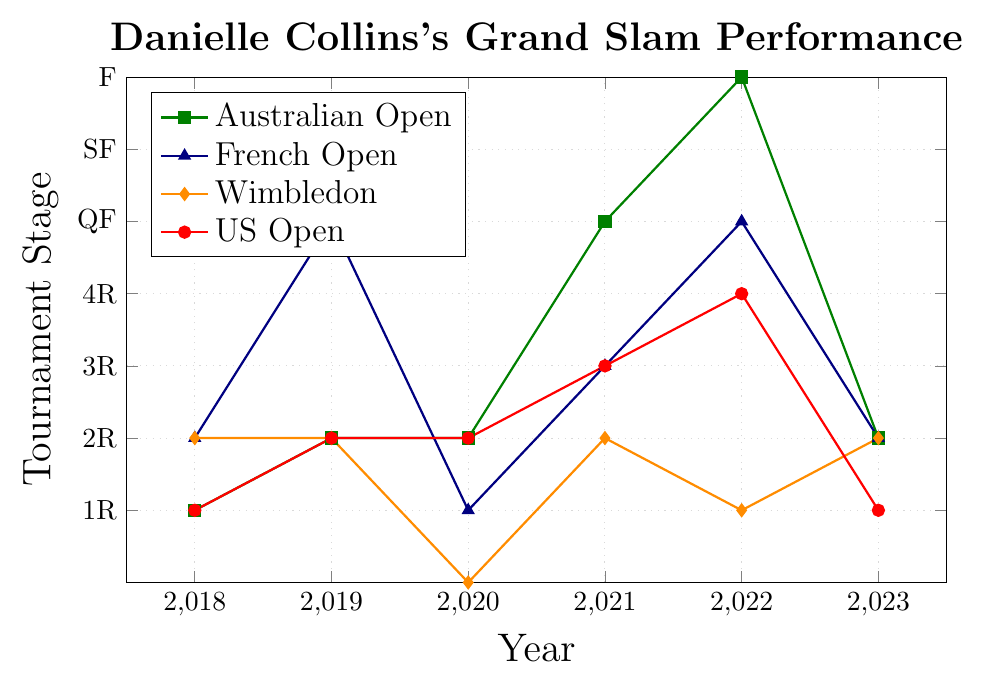what is the highest stage Danielle Collins reached in the Australian Open? To find the highest stage in the Australian Open, look at the highest data point in the Australian Open series. The highest stage is the final (F) in 2022.
Answer: F Between which years did Danielle Collins show the most improvement in the French Open? Evaluate the increase in stages year over year for the French Open and find the years with the largest positive change. The biggest improvement was from 2018 (2R) to 2019 (QF).
Answer: 2018 to 2019 Which Grand Slam did Danielle Collins perform consistently over time? Check the variation in results across all years for each tournament and identify the one with the least variance. Wimbledon shows the most consistent performance with mostly 2R results, except for NC in 2020 and 1R in 2022.
Answer: Wimbledon In which year did Danielle Collins have the highest aggregate performance across all Grand Slams? To find this, calculate the sum of stages of all Grand Slams in each year, assigning numerical values to stages (1R=1, 2R=2, etc.). The highest total sum of stages is in 2022 (AO=7, FO=5, W=1, US=4), summing up to 17.
Answer: 2022 Did Danielle Collins improve in all Grand Slam tournaments in 2023 compared to 2022? Compare the stages reached in 2022 and 2023 for all Grand Slams. In 2023: AO (down), FO (down), W (improved), US (down). So, overall, she did not improve in all.
Answer: No Which Grand Slam did Danielle Collins reach the semifinals at first? By looking at each series, the first instance of 'SF' is in the 2021 Australian Open.
Answer: Australian Open For which tournament did Danielle Collins have the best relative performance improvement between 2018 and 2023? Compare the relative change from 2018 to 2023 for each tournament and find the one with the highest improvement ratio. French Open sees improvement from 2R to QF.
Answer: French Open How many times did Danielle Collins reach the quarterfinals or beyond in the US Open from 2018 to 2023? Look for occurrences of "QF," "SF," or "F" in the US Open data. She never reached these stages within the given years.
Answer: 0 What is the longest streak of reaching at least the second round (2R) in Wimbledon? Count consecutive years where her stage is 2R or higher. For Wimbledon, she always reached at least 2R except in 2022 (1R), so the longest streak is from 2018 to 2021, spanning 3 years.
Answer: 3 years When did Danielle Collins achieve her first quarter-final stage in any tournament? Look for the earliest instance of "QF" in the data for all tournaments. She first reached the QF stage in the 2019 French Open.
Answer: 2019 